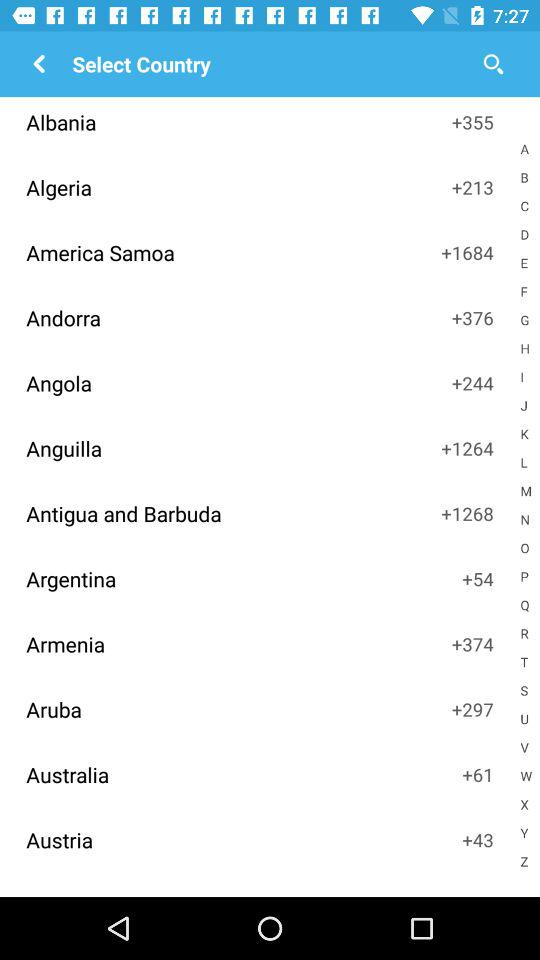What country has +43 as a country code? The country that has +43 as a country code is Austria. 